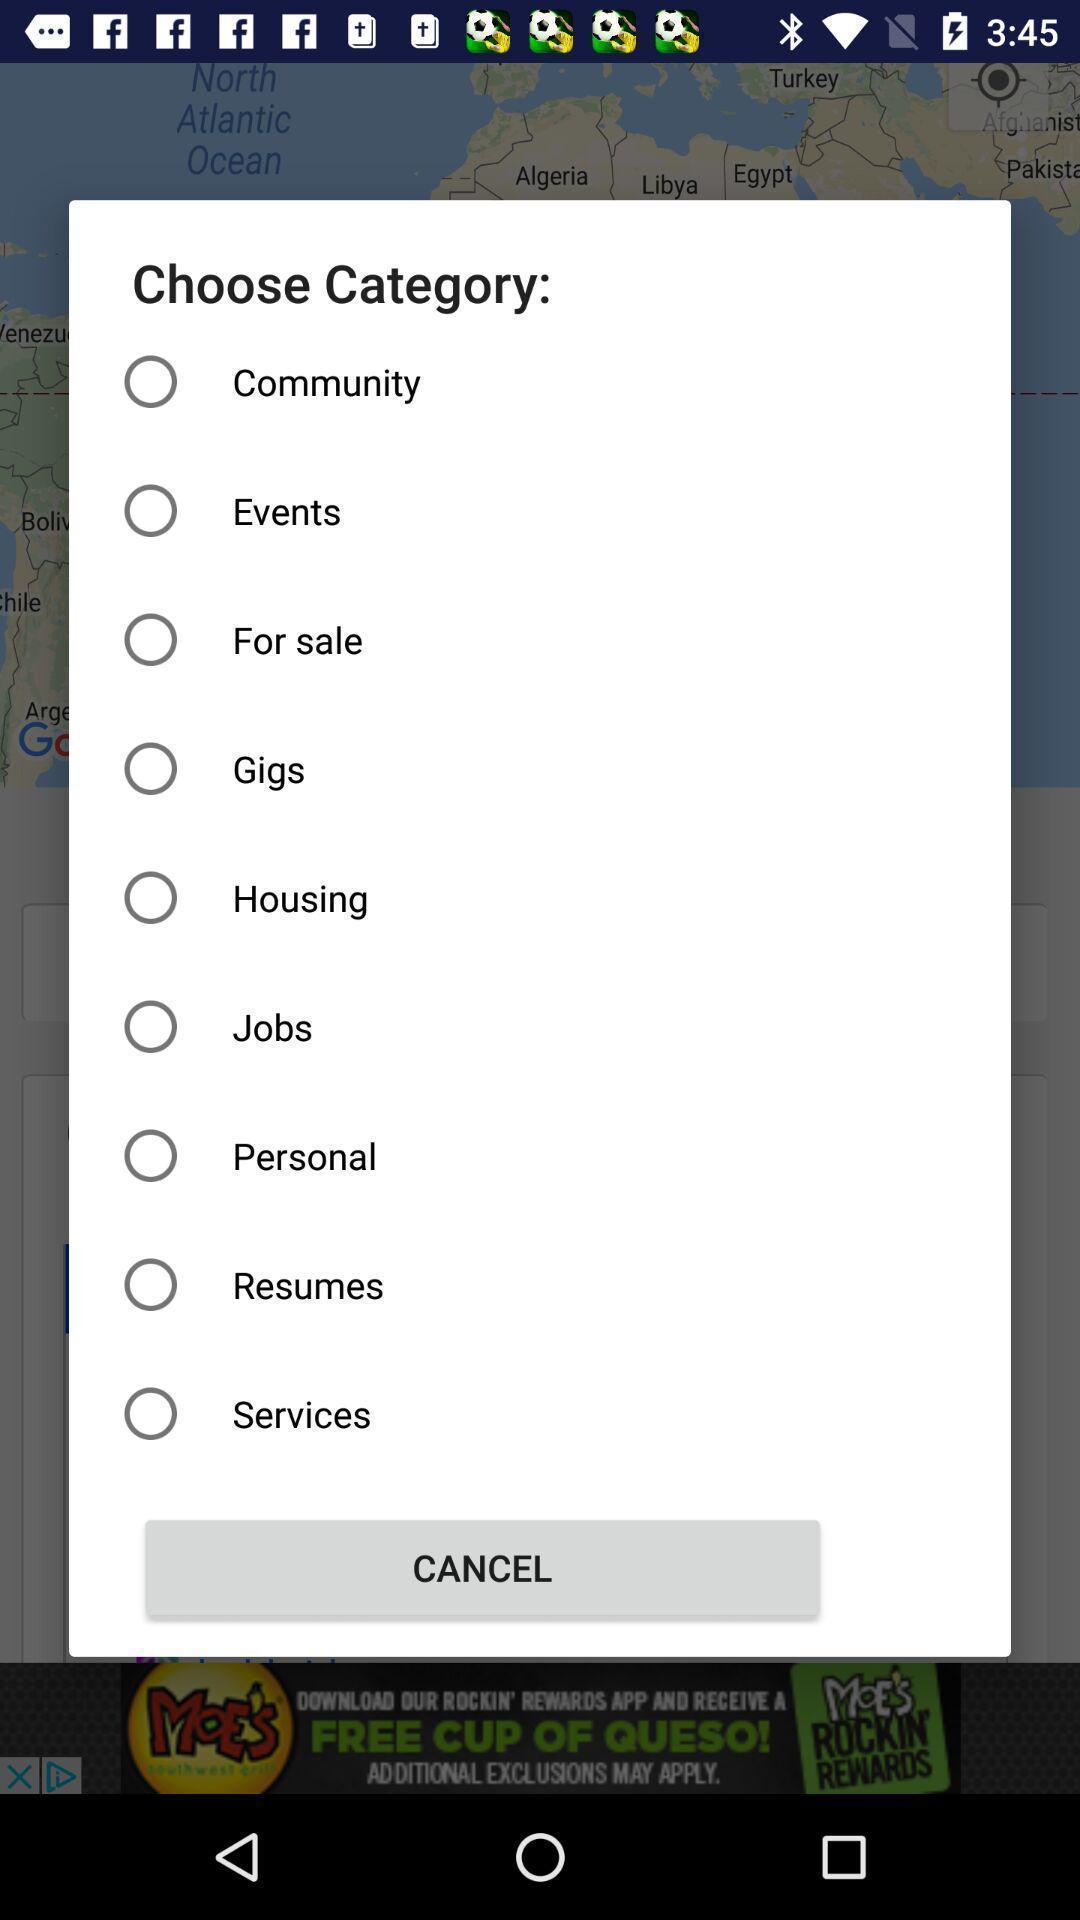Give me a narrative description of this picture. Popup showing categories to choose. 